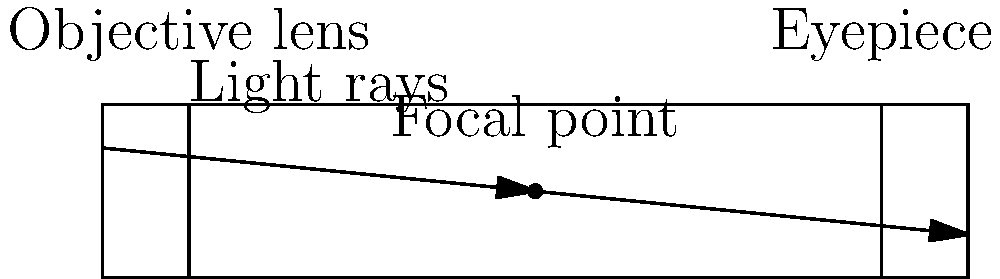As an aspiring politician interested in science education, you're visiting a local observatory in Gombe State. The astronomer shows you a simple cross-section diagram of a refracting telescope. Based on this diagram, what is the primary function of the objective lens in a refracting telescope? To understand the function of the objective lens in a refracting telescope, let's break down the diagram and the telescope's operation:

1. Light enters the telescope from the left side of the diagram.

2. The first lens encountered by the light is the objective lens, located at the front of the telescope.

3. The light rays are shown converging after passing through the objective lens, meeting at a point in the middle of the telescope.

4. This point where the light rays converge is called the focal point.

5. After the focal point, the light rays continue to the eyepiece lens on the right side of the telescope.

6. The eyepiece lens then magnifies the image for the observer to view.

The primary function of the objective lens can be deduced from its effect on the incoming light:

- It collects light from distant objects.
- It bends (refracts) the light rays, causing them to converge.
- By converging the light rays, it forms a real image of the distant object at the focal point.

This convergence of light is crucial because it allows the telescope to gather more light than the human eye alone, making dim objects visible. Additionally, by forming a real image, it enables the eyepiece to magnify this image, allowing for detailed observation of celestial objects.
Answer: To collect and focus light from distant objects, forming a real image at the focal point. 